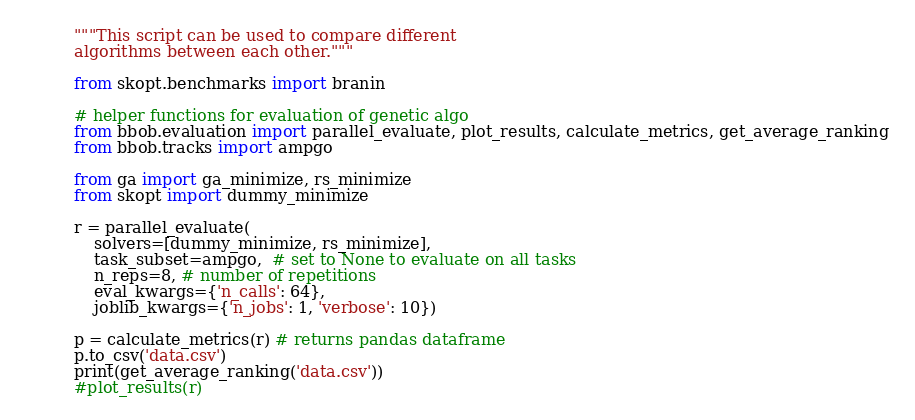Convert code to text. <code><loc_0><loc_0><loc_500><loc_500><_Python_>"""This script can be used to compare different 
algorithms between each other."""

from skopt.benchmarks import branin

# helper functions for evaluation of genetic algo
from bbob.evaluation import parallel_evaluate, plot_results, calculate_metrics, get_average_ranking
from bbob.tracks import ampgo

from ga import ga_minimize, rs_minimize
from skopt import dummy_minimize

r = parallel_evaluate(
    solvers=[dummy_minimize, rs_minimize],
    task_subset=ampgo,  # set to None to evaluate on all tasks
    n_reps=8, # number of repetitions
    eval_kwargs={'n_calls': 64},
    joblib_kwargs={'n_jobs': 1, 'verbose': 10})

p = calculate_metrics(r) # returns pandas dataframe
p.to_csv('data.csv')
print(get_average_ranking('data.csv'))
#plot_results(r)
</code> 